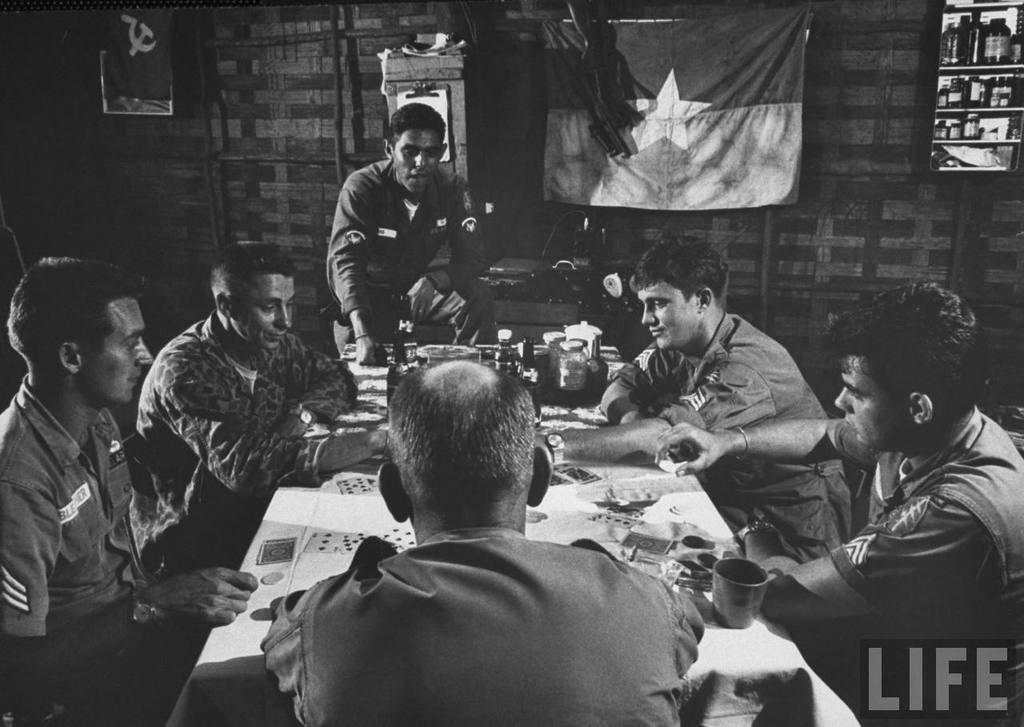Describe this image in one or two sentences. In the middle there is a table on that, there are playing cards ,cup and some other items ,in front of the table there are six people on that on the right there is a man he wear shirt. In the middle there is a man. On the left there are two men. In the background there is a flag ,cupboard ,bottles. 